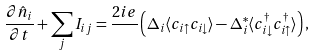Convert formula to latex. <formula><loc_0><loc_0><loc_500><loc_500>\frac { \partial \hat { n } _ { i } } { \partial t } + \sum _ { j } I _ { i j } = \frac { 2 i e } { } \left ( \Delta _ { i } \langle c _ { i \uparrow } c _ { i \downarrow } \rangle - \Delta ^ { * } _ { i } \langle c _ { i \downarrow } ^ { \dag } c _ { i \uparrow } ^ { \dag } \rangle \right ) ,</formula> 